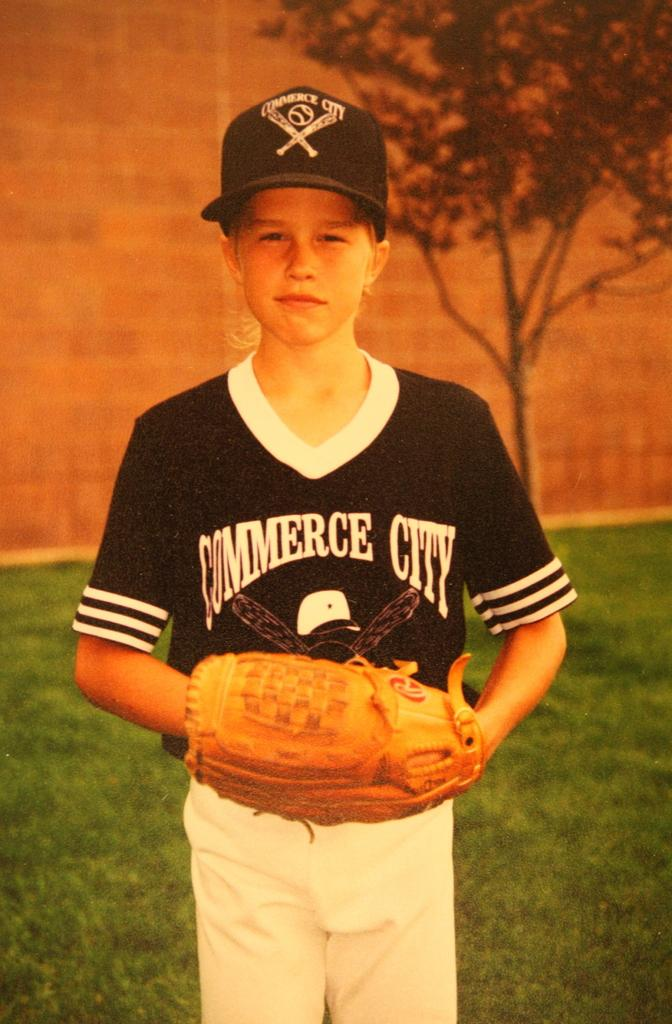Provide a one-sentence caption for the provided image. Little League baseball player wearing a shirt that says Commerce City. 